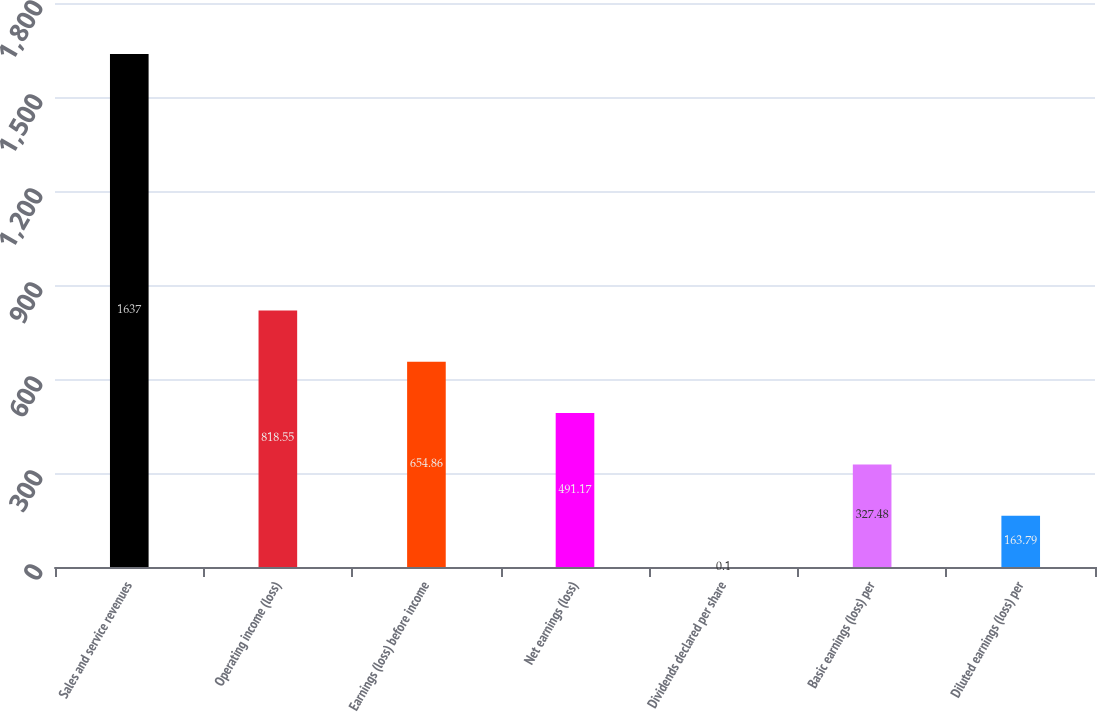Convert chart. <chart><loc_0><loc_0><loc_500><loc_500><bar_chart><fcel>Sales and service revenues<fcel>Operating income (loss)<fcel>Earnings (loss) before income<fcel>Net earnings (loss)<fcel>Dividends declared per share<fcel>Basic earnings (loss) per<fcel>Diluted earnings (loss) per<nl><fcel>1637<fcel>818.55<fcel>654.86<fcel>491.17<fcel>0.1<fcel>327.48<fcel>163.79<nl></chart> 